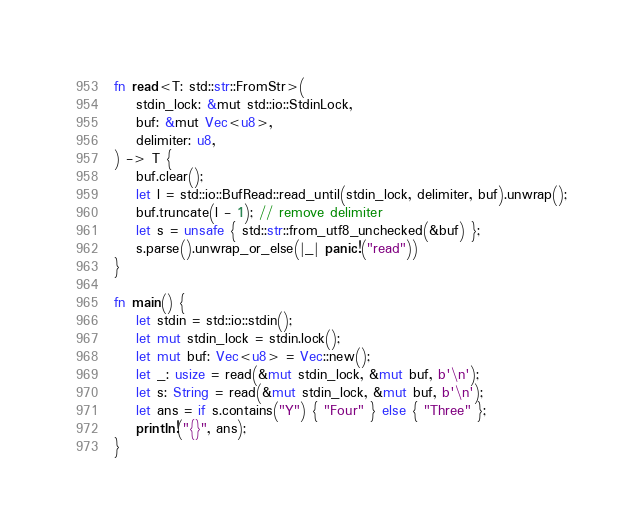Convert code to text. <code><loc_0><loc_0><loc_500><loc_500><_Rust_>fn read<T: std::str::FromStr>(
    stdin_lock: &mut std::io::StdinLock,
    buf: &mut Vec<u8>,
    delimiter: u8,
) -> T {
    buf.clear();
    let l = std::io::BufRead::read_until(stdin_lock, delimiter, buf).unwrap();
    buf.truncate(l - 1); // remove delimiter
    let s = unsafe { std::str::from_utf8_unchecked(&buf) };
    s.parse().unwrap_or_else(|_| panic!("read"))
}

fn main() {
    let stdin = std::io::stdin();
    let mut stdin_lock = stdin.lock();
    let mut buf: Vec<u8> = Vec::new();
    let _: usize = read(&mut stdin_lock, &mut buf, b'\n');
    let s: String = read(&mut stdin_lock, &mut buf, b'\n');
    let ans = if s.contains("Y") { "Four" } else { "Three" };
    println!("{}", ans);
}
</code> 